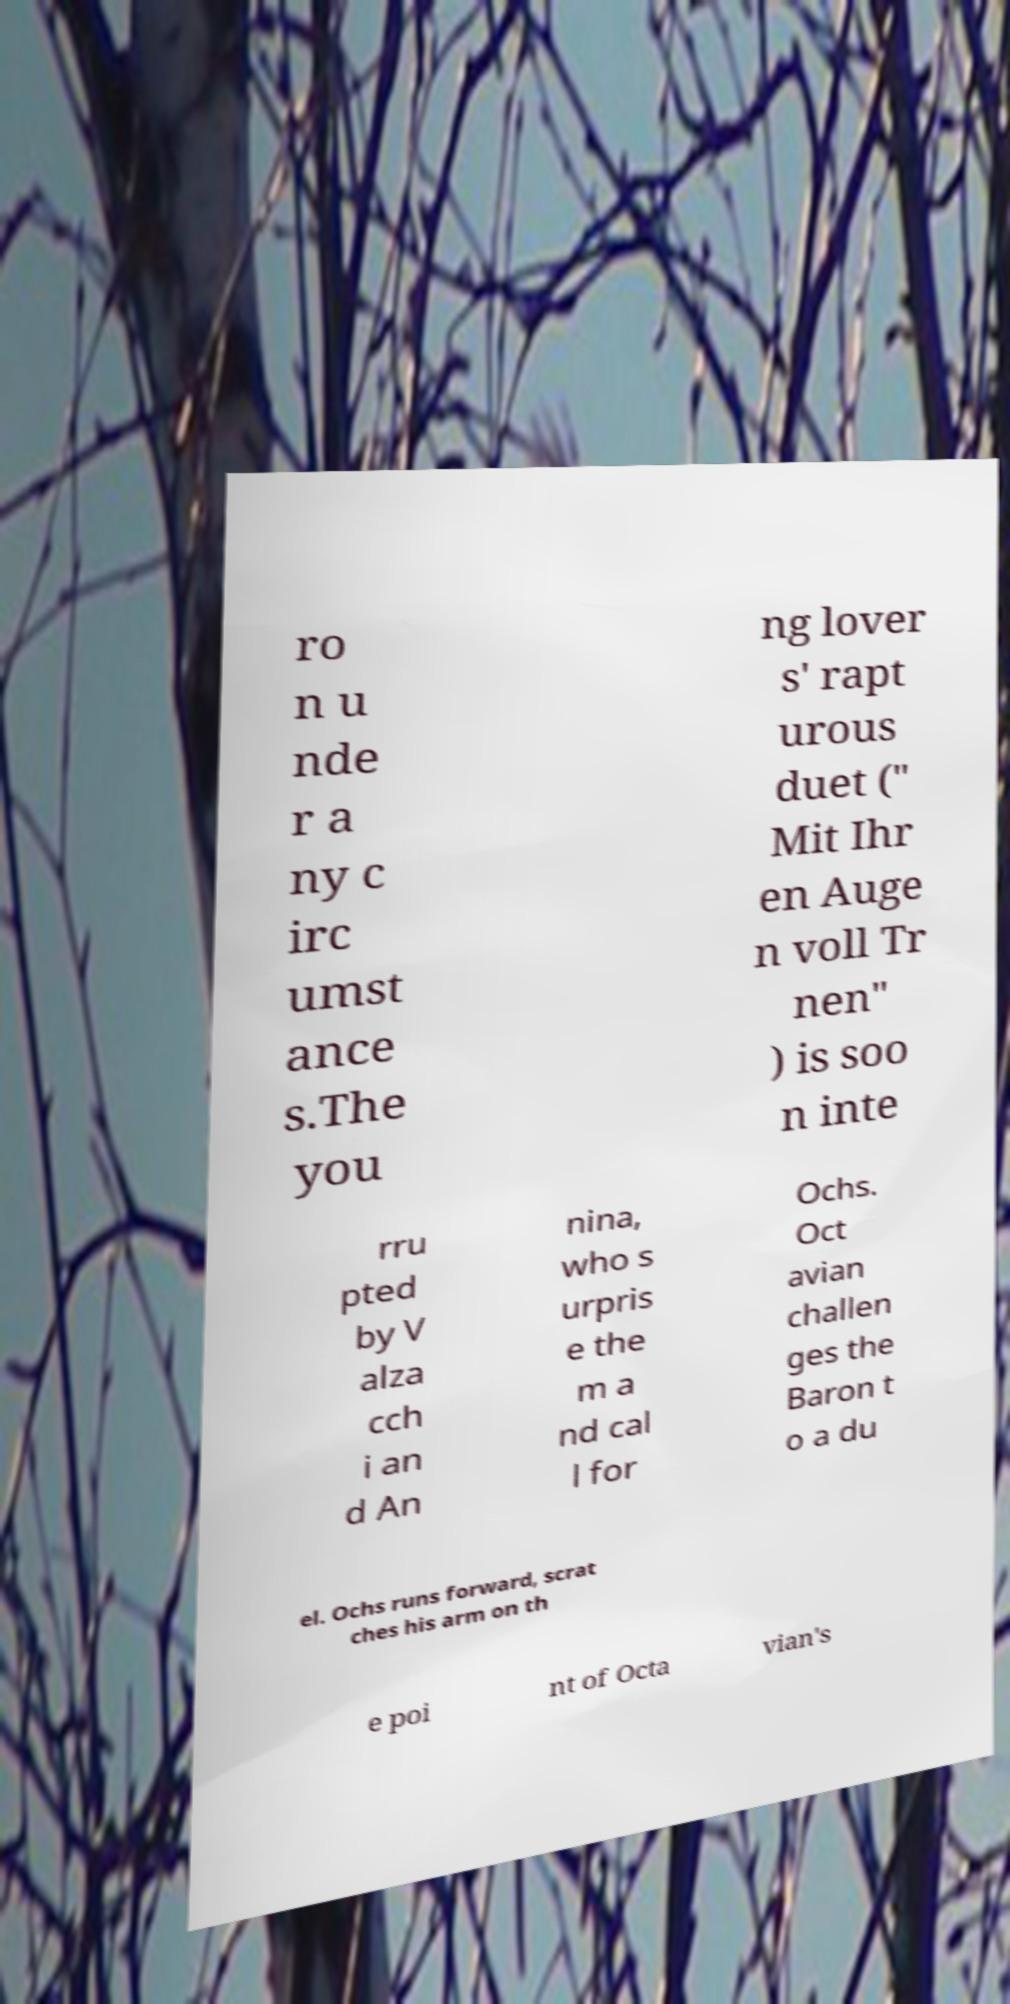There's text embedded in this image that I need extracted. Can you transcribe it verbatim? ro n u nde r a ny c irc umst ance s.The you ng lover s' rapt urous duet (" Mit Ihr en Auge n voll Tr nen" ) is soo n inte rru pted by V alza cch i an d An nina, who s urpris e the m a nd cal l for Ochs. Oct avian challen ges the Baron t o a du el. Ochs runs forward, scrat ches his arm on th e poi nt of Octa vian's 